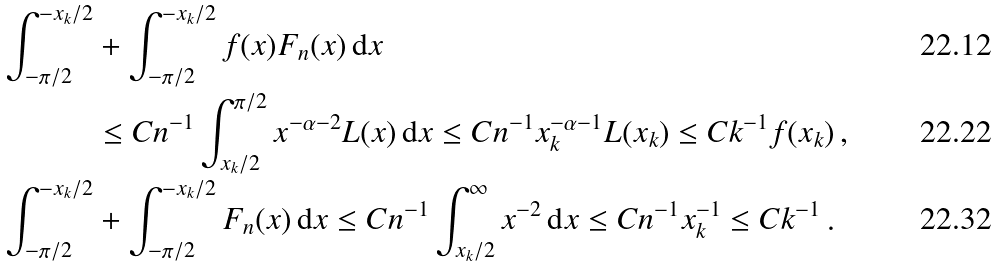Convert formula to latex. <formula><loc_0><loc_0><loc_500><loc_500>\int _ { - \pi / 2 } ^ { - x _ { k } / 2 } & + \int _ { - \pi / 2 } ^ { - x _ { k } / 2 } f ( x ) F _ { n } ( x ) \, \mathrm d x \\ & \leq C n ^ { - 1 } \int _ { x _ { k } / 2 } ^ { \pi / 2 } x ^ { - \alpha - 2 } L ( x ) \, \mathrm d x \leq C n ^ { - 1 } x _ { k } ^ { - \alpha - 1 } L ( x _ { k } ) \leq C k ^ { - 1 } f ( x _ { k } ) \, , \\ \int _ { - \pi / 2 } ^ { - x _ { k } / 2 } & + \int _ { - \pi / 2 } ^ { - x _ { k } / 2 } F _ { n } ( x ) \, \mathrm d x \leq C n ^ { - 1 } \int _ { x _ { k } / 2 } ^ { \infty } x ^ { - 2 } \, \mathrm d x \leq C n ^ { - 1 } x _ { k } ^ { - 1 } \leq C k ^ { - 1 } \, .</formula> 